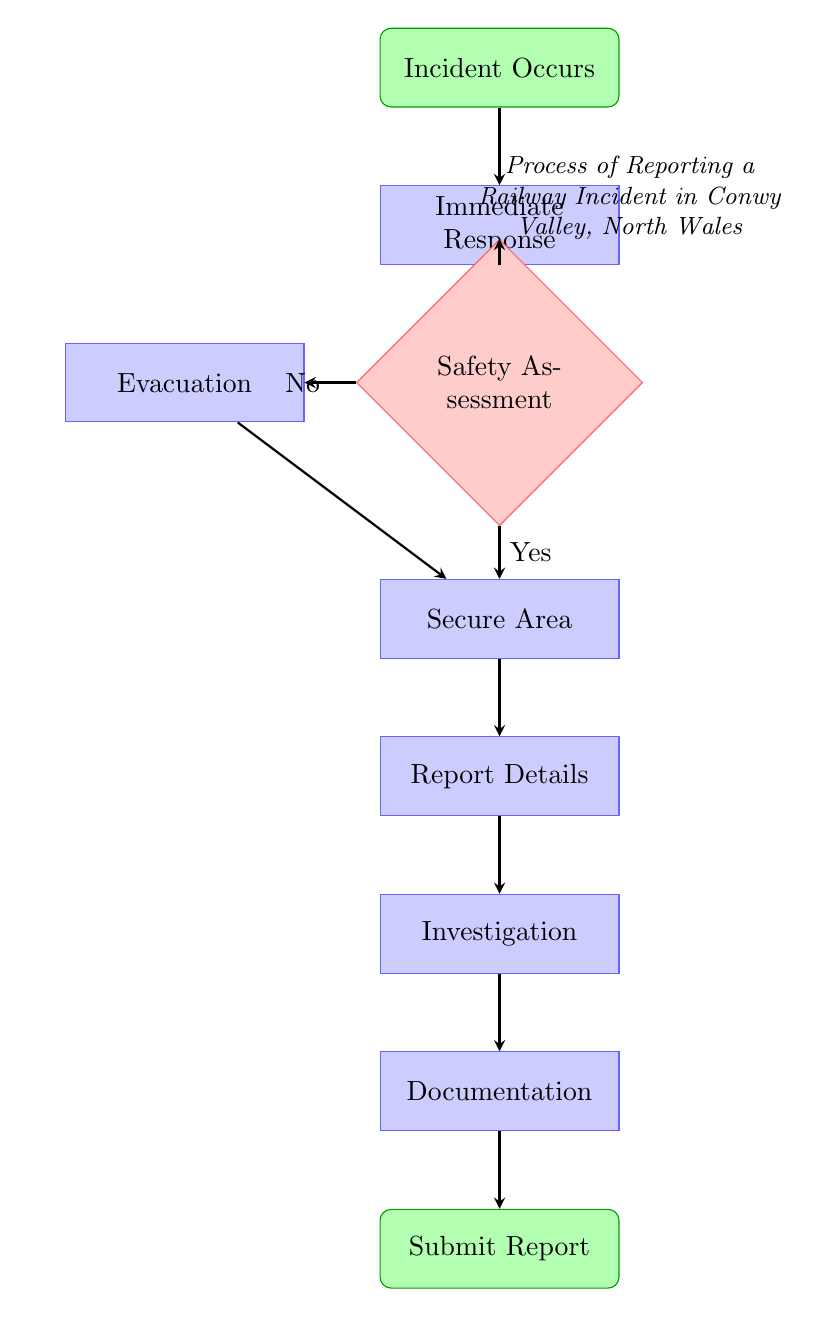What is the starting point of the process? The starting point of the process is labeled as "Incident Occurs" in the diagram. This is indicated by the first node in the flow chart, which represents the initial event that triggers the reporting process.
Answer: Incident Occurs How many process nodes are in the diagram? There are five process nodes in the diagram: "Immediate Response," "Evacuation," "Secure Area," "Report Details," and "Investigation." Counting these nodes gives the total number of process nodes specified.
Answer: Five What happens if the area is deemed safe? If the area is deemed safe (indicated by the "Yes" arrow from the "Safety Assessment" node), the next step is to "Secure Area." This shows the action taken following a positive safety assessment.
Answer: Secure Area What is done after reporting details to the British Transport Police? After reporting details to the British Transport Police, the next step is to commence the incident investigation. This continues the flow from the "Report Details" node to the "Investigation" node.
Answer: Investigation What is the end result of this reporting process? The end result of this reporting process is to "Submit full report to ORR." This is the final node in the flow, indicating the completion of the entire incident reporting procedure.
Answer: Submit full report to ORR What decision follows the immediate response? The decision that follows the immediate response is the "Safety Assessment." This decision determines whether the area is safe or not, which is crucial for determining the next steps in the process.
Answer: Safety Assessment Which process node comes after evacuation? After the "Evacuation" process node, the next step is to "Secure Area." This is seen in the flow as the "Evacuation" node connects to "Secure Area," indicating that securing the area is necessary following evacuation.
Answer: Secure Area If the area is not safe, which action will be taken next? If the area is not safe, the next action will be "Evacuation," as indicated by the "No" condition from the "Safety Assessment" node that directs the flow to "Evacuation."
Answer: Evacuation 